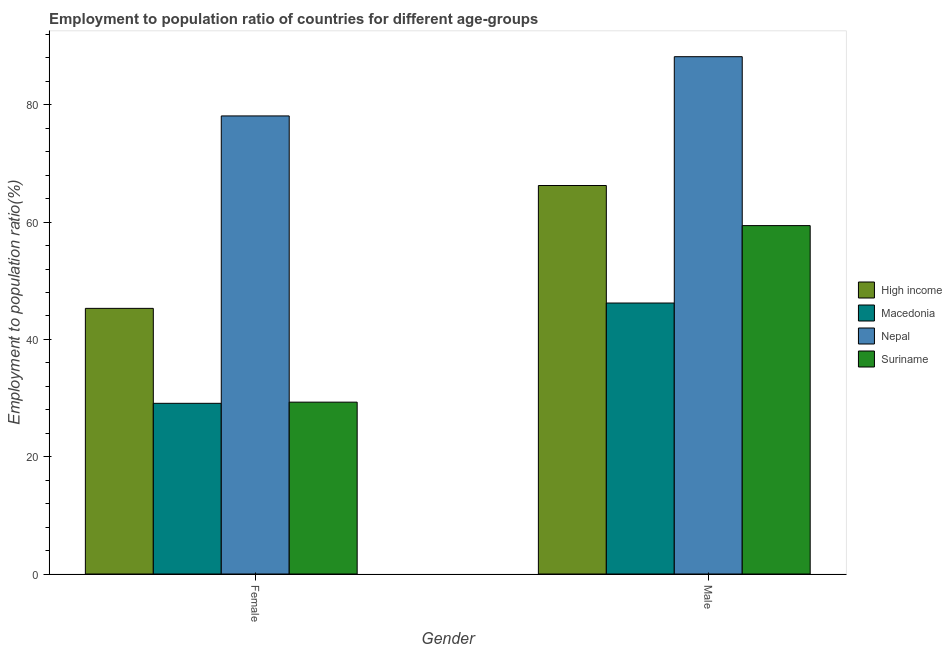How many bars are there on the 1st tick from the left?
Ensure brevity in your answer.  4. What is the label of the 2nd group of bars from the left?
Keep it short and to the point. Male. What is the employment to population ratio(female) in Macedonia?
Provide a short and direct response. 29.1. Across all countries, what is the maximum employment to population ratio(male)?
Keep it short and to the point. 88.2. Across all countries, what is the minimum employment to population ratio(female)?
Your answer should be compact. 29.1. In which country was the employment to population ratio(female) maximum?
Your answer should be compact. Nepal. In which country was the employment to population ratio(male) minimum?
Offer a terse response. Macedonia. What is the total employment to population ratio(female) in the graph?
Keep it short and to the point. 181.79. What is the difference between the employment to population ratio(female) in High income and that in Nepal?
Provide a succinct answer. -32.81. What is the difference between the employment to population ratio(female) in High income and the employment to population ratio(male) in Macedonia?
Your response must be concise. -0.91. What is the average employment to population ratio(male) per country?
Your response must be concise. 65.01. What is the difference between the employment to population ratio(male) and employment to population ratio(female) in Suriname?
Your answer should be compact. 30.1. What is the ratio of the employment to population ratio(female) in Nepal to that in High income?
Your response must be concise. 1.72. Is the employment to population ratio(male) in Nepal less than that in Suriname?
Offer a very short reply. No. What does the 4th bar from the left in Female represents?
Keep it short and to the point. Suriname. Are all the bars in the graph horizontal?
Offer a terse response. No. What is the difference between two consecutive major ticks on the Y-axis?
Keep it short and to the point. 20. Are the values on the major ticks of Y-axis written in scientific E-notation?
Provide a short and direct response. No. How are the legend labels stacked?
Provide a short and direct response. Vertical. What is the title of the graph?
Provide a short and direct response. Employment to population ratio of countries for different age-groups. What is the label or title of the X-axis?
Ensure brevity in your answer.  Gender. What is the Employment to population ratio(%) in High income in Female?
Your answer should be compact. 45.29. What is the Employment to population ratio(%) in Macedonia in Female?
Offer a terse response. 29.1. What is the Employment to population ratio(%) in Nepal in Female?
Provide a short and direct response. 78.1. What is the Employment to population ratio(%) of Suriname in Female?
Keep it short and to the point. 29.3. What is the Employment to population ratio(%) in High income in Male?
Offer a terse response. 66.24. What is the Employment to population ratio(%) of Macedonia in Male?
Your response must be concise. 46.2. What is the Employment to population ratio(%) of Nepal in Male?
Your response must be concise. 88.2. What is the Employment to population ratio(%) in Suriname in Male?
Your answer should be compact. 59.4. Across all Gender, what is the maximum Employment to population ratio(%) in High income?
Offer a terse response. 66.24. Across all Gender, what is the maximum Employment to population ratio(%) of Macedonia?
Provide a short and direct response. 46.2. Across all Gender, what is the maximum Employment to population ratio(%) in Nepal?
Offer a very short reply. 88.2. Across all Gender, what is the maximum Employment to population ratio(%) in Suriname?
Provide a short and direct response. 59.4. Across all Gender, what is the minimum Employment to population ratio(%) of High income?
Provide a succinct answer. 45.29. Across all Gender, what is the minimum Employment to population ratio(%) of Macedonia?
Offer a terse response. 29.1. Across all Gender, what is the minimum Employment to population ratio(%) in Nepal?
Your answer should be compact. 78.1. Across all Gender, what is the minimum Employment to population ratio(%) of Suriname?
Ensure brevity in your answer.  29.3. What is the total Employment to population ratio(%) of High income in the graph?
Your answer should be compact. 111.53. What is the total Employment to population ratio(%) in Macedonia in the graph?
Your answer should be very brief. 75.3. What is the total Employment to population ratio(%) of Nepal in the graph?
Provide a succinct answer. 166.3. What is the total Employment to population ratio(%) of Suriname in the graph?
Offer a very short reply. 88.7. What is the difference between the Employment to population ratio(%) in High income in Female and that in Male?
Give a very brief answer. -20.95. What is the difference between the Employment to population ratio(%) of Macedonia in Female and that in Male?
Provide a short and direct response. -17.1. What is the difference between the Employment to population ratio(%) of Suriname in Female and that in Male?
Your answer should be very brief. -30.1. What is the difference between the Employment to population ratio(%) in High income in Female and the Employment to population ratio(%) in Macedonia in Male?
Your answer should be compact. -0.91. What is the difference between the Employment to population ratio(%) of High income in Female and the Employment to population ratio(%) of Nepal in Male?
Provide a short and direct response. -42.91. What is the difference between the Employment to population ratio(%) in High income in Female and the Employment to population ratio(%) in Suriname in Male?
Make the answer very short. -14.11. What is the difference between the Employment to population ratio(%) in Macedonia in Female and the Employment to population ratio(%) in Nepal in Male?
Give a very brief answer. -59.1. What is the difference between the Employment to population ratio(%) of Macedonia in Female and the Employment to population ratio(%) of Suriname in Male?
Your answer should be compact. -30.3. What is the difference between the Employment to population ratio(%) of Nepal in Female and the Employment to population ratio(%) of Suriname in Male?
Your answer should be very brief. 18.7. What is the average Employment to population ratio(%) in High income per Gender?
Offer a very short reply. 55.76. What is the average Employment to population ratio(%) of Macedonia per Gender?
Your answer should be compact. 37.65. What is the average Employment to population ratio(%) of Nepal per Gender?
Your answer should be compact. 83.15. What is the average Employment to population ratio(%) of Suriname per Gender?
Your answer should be very brief. 44.35. What is the difference between the Employment to population ratio(%) in High income and Employment to population ratio(%) in Macedonia in Female?
Your answer should be compact. 16.19. What is the difference between the Employment to population ratio(%) in High income and Employment to population ratio(%) in Nepal in Female?
Give a very brief answer. -32.81. What is the difference between the Employment to population ratio(%) in High income and Employment to population ratio(%) in Suriname in Female?
Ensure brevity in your answer.  15.99. What is the difference between the Employment to population ratio(%) in Macedonia and Employment to population ratio(%) in Nepal in Female?
Provide a succinct answer. -49. What is the difference between the Employment to population ratio(%) of Nepal and Employment to population ratio(%) of Suriname in Female?
Keep it short and to the point. 48.8. What is the difference between the Employment to population ratio(%) of High income and Employment to population ratio(%) of Macedonia in Male?
Provide a succinct answer. 20.04. What is the difference between the Employment to population ratio(%) of High income and Employment to population ratio(%) of Nepal in Male?
Your answer should be very brief. -21.96. What is the difference between the Employment to population ratio(%) in High income and Employment to population ratio(%) in Suriname in Male?
Your answer should be very brief. 6.84. What is the difference between the Employment to population ratio(%) in Macedonia and Employment to population ratio(%) in Nepal in Male?
Your answer should be compact. -42. What is the difference between the Employment to population ratio(%) of Nepal and Employment to population ratio(%) of Suriname in Male?
Keep it short and to the point. 28.8. What is the ratio of the Employment to population ratio(%) of High income in Female to that in Male?
Make the answer very short. 0.68. What is the ratio of the Employment to population ratio(%) in Macedonia in Female to that in Male?
Your response must be concise. 0.63. What is the ratio of the Employment to population ratio(%) in Nepal in Female to that in Male?
Provide a succinct answer. 0.89. What is the ratio of the Employment to population ratio(%) in Suriname in Female to that in Male?
Your answer should be very brief. 0.49. What is the difference between the highest and the second highest Employment to population ratio(%) in High income?
Your answer should be compact. 20.95. What is the difference between the highest and the second highest Employment to population ratio(%) in Macedonia?
Provide a succinct answer. 17.1. What is the difference between the highest and the second highest Employment to population ratio(%) of Nepal?
Provide a short and direct response. 10.1. What is the difference between the highest and the second highest Employment to population ratio(%) in Suriname?
Provide a short and direct response. 30.1. What is the difference between the highest and the lowest Employment to population ratio(%) of High income?
Provide a short and direct response. 20.95. What is the difference between the highest and the lowest Employment to population ratio(%) in Macedonia?
Keep it short and to the point. 17.1. What is the difference between the highest and the lowest Employment to population ratio(%) of Suriname?
Make the answer very short. 30.1. 